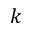<formula> <loc_0><loc_0><loc_500><loc_500>k</formula> 